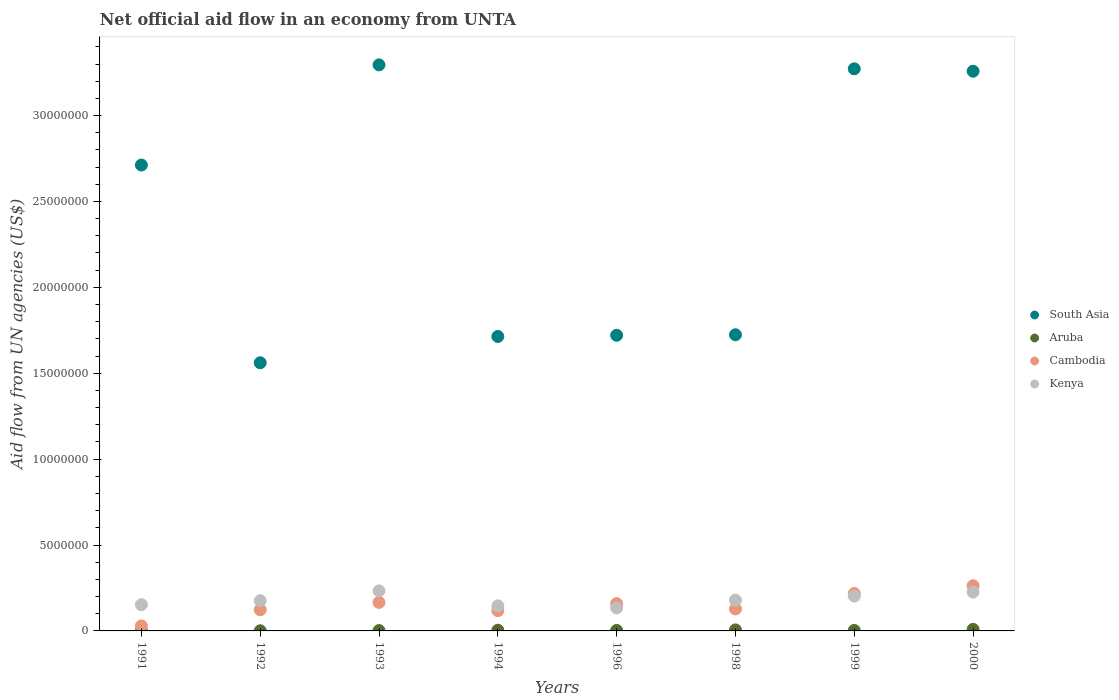What is the net official aid flow in South Asia in 1992?
Provide a succinct answer. 1.56e+07. Across all years, what is the minimum net official aid flow in Aruba?
Make the answer very short. 10000. In which year was the net official aid flow in Kenya maximum?
Make the answer very short. 1993. In which year was the net official aid flow in Cambodia minimum?
Offer a terse response. 1991. What is the total net official aid flow in South Asia in the graph?
Offer a terse response. 1.93e+08. What is the difference between the net official aid flow in Cambodia in 1991 and that in 2000?
Offer a terse response. -2.34e+06. What is the difference between the net official aid flow in Kenya in 1993 and the net official aid flow in Cambodia in 1991?
Keep it short and to the point. 2.04e+06. What is the average net official aid flow in Kenya per year?
Provide a short and direct response. 1.81e+06. In the year 1999, what is the difference between the net official aid flow in Aruba and net official aid flow in South Asia?
Make the answer very short. -3.27e+07. In how many years, is the net official aid flow in Cambodia greater than 25000000 US$?
Give a very brief answer. 0. What is the ratio of the net official aid flow in Cambodia in 1992 to that in 1996?
Ensure brevity in your answer.  0.77. What is the difference between the highest and the second highest net official aid flow in South Asia?
Offer a terse response. 2.30e+05. What is the difference between the highest and the lowest net official aid flow in Kenya?
Your response must be concise. 9.90e+05. Is it the case that in every year, the sum of the net official aid flow in South Asia and net official aid flow in Kenya  is greater than the sum of net official aid flow in Cambodia and net official aid flow in Aruba?
Your response must be concise. No. Is it the case that in every year, the sum of the net official aid flow in Aruba and net official aid flow in South Asia  is greater than the net official aid flow in Kenya?
Offer a terse response. Yes. How many dotlines are there?
Provide a succinct answer. 4. What is the difference between two consecutive major ticks on the Y-axis?
Your answer should be compact. 5.00e+06. Are the values on the major ticks of Y-axis written in scientific E-notation?
Ensure brevity in your answer.  No. Does the graph contain any zero values?
Offer a very short reply. No. Does the graph contain grids?
Provide a succinct answer. No. How are the legend labels stacked?
Your answer should be very brief. Vertical. What is the title of the graph?
Provide a short and direct response. Net official aid flow in an economy from UNTA. Does "Argentina" appear as one of the legend labels in the graph?
Offer a very short reply. No. What is the label or title of the Y-axis?
Your answer should be compact. Aid flow from UN agencies (US$). What is the Aid flow from UN agencies (US$) in South Asia in 1991?
Provide a succinct answer. 2.71e+07. What is the Aid flow from UN agencies (US$) of Cambodia in 1991?
Your answer should be very brief. 2.90e+05. What is the Aid flow from UN agencies (US$) in Kenya in 1991?
Your response must be concise. 1.53e+06. What is the Aid flow from UN agencies (US$) in South Asia in 1992?
Give a very brief answer. 1.56e+07. What is the Aid flow from UN agencies (US$) in Aruba in 1992?
Offer a terse response. 10000. What is the Aid flow from UN agencies (US$) in Cambodia in 1992?
Make the answer very short. 1.23e+06. What is the Aid flow from UN agencies (US$) in Kenya in 1992?
Offer a terse response. 1.76e+06. What is the Aid flow from UN agencies (US$) of South Asia in 1993?
Offer a very short reply. 3.30e+07. What is the Aid flow from UN agencies (US$) of Aruba in 1993?
Your answer should be very brief. 2.00e+04. What is the Aid flow from UN agencies (US$) of Cambodia in 1993?
Provide a succinct answer. 1.66e+06. What is the Aid flow from UN agencies (US$) of Kenya in 1993?
Provide a succinct answer. 2.33e+06. What is the Aid flow from UN agencies (US$) in South Asia in 1994?
Provide a succinct answer. 1.71e+07. What is the Aid flow from UN agencies (US$) in Aruba in 1994?
Ensure brevity in your answer.  4.00e+04. What is the Aid flow from UN agencies (US$) of Cambodia in 1994?
Offer a terse response. 1.18e+06. What is the Aid flow from UN agencies (US$) in Kenya in 1994?
Ensure brevity in your answer.  1.46e+06. What is the Aid flow from UN agencies (US$) in South Asia in 1996?
Your answer should be compact. 1.72e+07. What is the Aid flow from UN agencies (US$) in Aruba in 1996?
Your answer should be very brief. 3.00e+04. What is the Aid flow from UN agencies (US$) of Cambodia in 1996?
Make the answer very short. 1.59e+06. What is the Aid flow from UN agencies (US$) of Kenya in 1996?
Provide a succinct answer. 1.34e+06. What is the Aid flow from UN agencies (US$) of South Asia in 1998?
Provide a short and direct response. 1.72e+07. What is the Aid flow from UN agencies (US$) of Cambodia in 1998?
Ensure brevity in your answer.  1.28e+06. What is the Aid flow from UN agencies (US$) in Kenya in 1998?
Give a very brief answer. 1.79e+06. What is the Aid flow from UN agencies (US$) of South Asia in 1999?
Ensure brevity in your answer.  3.27e+07. What is the Aid flow from UN agencies (US$) in Cambodia in 1999?
Keep it short and to the point. 2.18e+06. What is the Aid flow from UN agencies (US$) of Kenya in 1999?
Keep it short and to the point. 2.03e+06. What is the Aid flow from UN agencies (US$) of South Asia in 2000?
Provide a short and direct response. 3.26e+07. What is the Aid flow from UN agencies (US$) in Aruba in 2000?
Make the answer very short. 9.00e+04. What is the Aid flow from UN agencies (US$) in Cambodia in 2000?
Your answer should be very brief. 2.63e+06. What is the Aid flow from UN agencies (US$) in Kenya in 2000?
Ensure brevity in your answer.  2.26e+06. Across all years, what is the maximum Aid flow from UN agencies (US$) in South Asia?
Give a very brief answer. 3.30e+07. Across all years, what is the maximum Aid flow from UN agencies (US$) in Aruba?
Give a very brief answer. 9.00e+04. Across all years, what is the maximum Aid flow from UN agencies (US$) of Cambodia?
Offer a terse response. 2.63e+06. Across all years, what is the maximum Aid flow from UN agencies (US$) in Kenya?
Provide a short and direct response. 2.33e+06. Across all years, what is the minimum Aid flow from UN agencies (US$) of South Asia?
Give a very brief answer. 1.56e+07. Across all years, what is the minimum Aid flow from UN agencies (US$) in Cambodia?
Offer a terse response. 2.90e+05. Across all years, what is the minimum Aid flow from UN agencies (US$) in Kenya?
Keep it short and to the point. 1.34e+06. What is the total Aid flow from UN agencies (US$) in South Asia in the graph?
Provide a short and direct response. 1.93e+08. What is the total Aid flow from UN agencies (US$) of Cambodia in the graph?
Provide a short and direct response. 1.20e+07. What is the total Aid flow from UN agencies (US$) of Kenya in the graph?
Provide a short and direct response. 1.45e+07. What is the difference between the Aid flow from UN agencies (US$) of South Asia in 1991 and that in 1992?
Keep it short and to the point. 1.15e+07. What is the difference between the Aid flow from UN agencies (US$) in Cambodia in 1991 and that in 1992?
Your answer should be very brief. -9.40e+05. What is the difference between the Aid flow from UN agencies (US$) in South Asia in 1991 and that in 1993?
Offer a very short reply. -5.83e+06. What is the difference between the Aid flow from UN agencies (US$) of Cambodia in 1991 and that in 1993?
Offer a very short reply. -1.37e+06. What is the difference between the Aid flow from UN agencies (US$) of Kenya in 1991 and that in 1993?
Make the answer very short. -8.00e+05. What is the difference between the Aid flow from UN agencies (US$) in South Asia in 1991 and that in 1994?
Your response must be concise. 9.98e+06. What is the difference between the Aid flow from UN agencies (US$) in Aruba in 1991 and that in 1994?
Give a very brief answer. -3.00e+04. What is the difference between the Aid flow from UN agencies (US$) of Cambodia in 1991 and that in 1994?
Keep it short and to the point. -8.90e+05. What is the difference between the Aid flow from UN agencies (US$) in South Asia in 1991 and that in 1996?
Give a very brief answer. 9.91e+06. What is the difference between the Aid flow from UN agencies (US$) of Cambodia in 1991 and that in 1996?
Your answer should be compact. -1.30e+06. What is the difference between the Aid flow from UN agencies (US$) of South Asia in 1991 and that in 1998?
Provide a short and direct response. 9.88e+06. What is the difference between the Aid flow from UN agencies (US$) in Cambodia in 1991 and that in 1998?
Your response must be concise. -9.90e+05. What is the difference between the Aid flow from UN agencies (US$) in South Asia in 1991 and that in 1999?
Offer a terse response. -5.60e+06. What is the difference between the Aid flow from UN agencies (US$) of Aruba in 1991 and that in 1999?
Your answer should be very brief. -2.00e+04. What is the difference between the Aid flow from UN agencies (US$) in Cambodia in 1991 and that in 1999?
Ensure brevity in your answer.  -1.89e+06. What is the difference between the Aid flow from UN agencies (US$) in Kenya in 1991 and that in 1999?
Offer a terse response. -5.00e+05. What is the difference between the Aid flow from UN agencies (US$) of South Asia in 1991 and that in 2000?
Ensure brevity in your answer.  -5.46e+06. What is the difference between the Aid flow from UN agencies (US$) of Cambodia in 1991 and that in 2000?
Your answer should be very brief. -2.34e+06. What is the difference between the Aid flow from UN agencies (US$) in Kenya in 1991 and that in 2000?
Make the answer very short. -7.30e+05. What is the difference between the Aid flow from UN agencies (US$) of South Asia in 1992 and that in 1993?
Keep it short and to the point. -1.73e+07. What is the difference between the Aid flow from UN agencies (US$) of Aruba in 1992 and that in 1993?
Ensure brevity in your answer.  -10000. What is the difference between the Aid flow from UN agencies (US$) of Cambodia in 1992 and that in 1993?
Make the answer very short. -4.30e+05. What is the difference between the Aid flow from UN agencies (US$) in Kenya in 1992 and that in 1993?
Give a very brief answer. -5.70e+05. What is the difference between the Aid flow from UN agencies (US$) of South Asia in 1992 and that in 1994?
Ensure brevity in your answer.  -1.53e+06. What is the difference between the Aid flow from UN agencies (US$) of Aruba in 1992 and that in 1994?
Ensure brevity in your answer.  -3.00e+04. What is the difference between the Aid flow from UN agencies (US$) of Cambodia in 1992 and that in 1994?
Provide a short and direct response. 5.00e+04. What is the difference between the Aid flow from UN agencies (US$) in South Asia in 1992 and that in 1996?
Your response must be concise. -1.60e+06. What is the difference between the Aid flow from UN agencies (US$) in Aruba in 1992 and that in 1996?
Keep it short and to the point. -2.00e+04. What is the difference between the Aid flow from UN agencies (US$) in Cambodia in 1992 and that in 1996?
Give a very brief answer. -3.60e+05. What is the difference between the Aid flow from UN agencies (US$) of South Asia in 1992 and that in 1998?
Provide a short and direct response. -1.63e+06. What is the difference between the Aid flow from UN agencies (US$) in Aruba in 1992 and that in 1998?
Provide a succinct answer. -5.00e+04. What is the difference between the Aid flow from UN agencies (US$) of South Asia in 1992 and that in 1999?
Keep it short and to the point. -1.71e+07. What is the difference between the Aid flow from UN agencies (US$) of Aruba in 1992 and that in 1999?
Ensure brevity in your answer.  -2.00e+04. What is the difference between the Aid flow from UN agencies (US$) in Cambodia in 1992 and that in 1999?
Offer a very short reply. -9.50e+05. What is the difference between the Aid flow from UN agencies (US$) in Kenya in 1992 and that in 1999?
Provide a succinct answer. -2.70e+05. What is the difference between the Aid flow from UN agencies (US$) of South Asia in 1992 and that in 2000?
Your response must be concise. -1.70e+07. What is the difference between the Aid flow from UN agencies (US$) in Aruba in 1992 and that in 2000?
Your answer should be very brief. -8.00e+04. What is the difference between the Aid flow from UN agencies (US$) in Cambodia in 1992 and that in 2000?
Give a very brief answer. -1.40e+06. What is the difference between the Aid flow from UN agencies (US$) in Kenya in 1992 and that in 2000?
Offer a very short reply. -5.00e+05. What is the difference between the Aid flow from UN agencies (US$) of South Asia in 1993 and that in 1994?
Make the answer very short. 1.58e+07. What is the difference between the Aid flow from UN agencies (US$) in Aruba in 1993 and that in 1994?
Offer a terse response. -2.00e+04. What is the difference between the Aid flow from UN agencies (US$) in Kenya in 1993 and that in 1994?
Offer a very short reply. 8.70e+05. What is the difference between the Aid flow from UN agencies (US$) in South Asia in 1993 and that in 1996?
Keep it short and to the point. 1.57e+07. What is the difference between the Aid flow from UN agencies (US$) in Aruba in 1993 and that in 1996?
Your answer should be compact. -10000. What is the difference between the Aid flow from UN agencies (US$) in Kenya in 1993 and that in 1996?
Make the answer very short. 9.90e+05. What is the difference between the Aid flow from UN agencies (US$) of South Asia in 1993 and that in 1998?
Offer a very short reply. 1.57e+07. What is the difference between the Aid flow from UN agencies (US$) of Kenya in 1993 and that in 1998?
Keep it short and to the point. 5.40e+05. What is the difference between the Aid flow from UN agencies (US$) in Cambodia in 1993 and that in 1999?
Make the answer very short. -5.20e+05. What is the difference between the Aid flow from UN agencies (US$) of Cambodia in 1993 and that in 2000?
Provide a short and direct response. -9.70e+05. What is the difference between the Aid flow from UN agencies (US$) of Kenya in 1993 and that in 2000?
Make the answer very short. 7.00e+04. What is the difference between the Aid flow from UN agencies (US$) of South Asia in 1994 and that in 1996?
Keep it short and to the point. -7.00e+04. What is the difference between the Aid flow from UN agencies (US$) in Aruba in 1994 and that in 1996?
Offer a very short reply. 10000. What is the difference between the Aid flow from UN agencies (US$) in Cambodia in 1994 and that in 1996?
Your response must be concise. -4.10e+05. What is the difference between the Aid flow from UN agencies (US$) in South Asia in 1994 and that in 1998?
Ensure brevity in your answer.  -1.00e+05. What is the difference between the Aid flow from UN agencies (US$) of Aruba in 1994 and that in 1998?
Your response must be concise. -2.00e+04. What is the difference between the Aid flow from UN agencies (US$) of Kenya in 1994 and that in 1998?
Offer a terse response. -3.30e+05. What is the difference between the Aid flow from UN agencies (US$) in South Asia in 1994 and that in 1999?
Offer a terse response. -1.56e+07. What is the difference between the Aid flow from UN agencies (US$) in Kenya in 1994 and that in 1999?
Keep it short and to the point. -5.70e+05. What is the difference between the Aid flow from UN agencies (US$) in South Asia in 1994 and that in 2000?
Give a very brief answer. -1.54e+07. What is the difference between the Aid flow from UN agencies (US$) of Cambodia in 1994 and that in 2000?
Keep it short and to the point. -1.45e+06. What is the difference between the Aid flow from UN agencies (US$) of Kenya in 1994 and that in 2000?
Provide a succinct answer. -8.00e+05. What is the difference between the Aid flow from UN agencies (US$) in South Asia in 1996 and that in 1998?
Provide a short and direct response. -3.00e+04. What is the difference between the Aid flow from UN agencies (US$) in Aruba in 1996 and that in 1998?
Provide a succinct answer. -3.00e+04. What is the difference between the Aid flow from UN agencies (US$) in Cambodia in 1996 and that in 1998?
Offer a terse response. 3.10e+05. What is the difference between the Aid flow from UN agencies (US$) of Kenya in 1996 and that in 1998?
Give a very brief answer. -4.50e+05. What is the difference between the Aid flow from UN agencies (US$) in South Asia in 1996 and that in 1999?
Offer a terse response. -1.55e+07. What is the difference between the Aid flow from UN agencies (US$) of Cambodia in 1996 and that in 1999?
Your response must be concise. -5.90e+05. What is the difference between the Aid flow from UN agencies (US$) in Kenya in 1996 and that in 1999?
Provide a short and direct response. -6.90e+05. What is the difference between the Aid flow from UN agencies (US$) of South Asia in 1996 and that in 2000?
Keep it short and to the point. -1.54e+07. What is the difference between the Aid flow from UN agencies (US$) of Cambodia in 1996 and that in 2000?
Your answer should be compact. -1.04e+06. What is the difference between the Aid flow from UN agencies (US$) in Kenya in 1996 and that in 2000?
Give a very brief answer. -9.20e+05. What is the difference between the Aid flow from UN agencies (US$) in South Asia in 1998 and that in 1999?
Make the answer very short. -1.55e+07. What is the difference between the Aid flow from UN agencies (US$) in Aruba in 1998 and that in 1999?
Your answer should be very brief. 3.00e+04. What is the difference between the Aid flow from UN agencies (US$) of Cambodia in 1998 and that in 1999?
Make the answer very short. -9.00e+05. What is the difference between the Aid flow from UN agencies (US$) of Kenya in 1998 and that in 1999?
Give a very brief answer. -2.40e+05. What is the difference between the Aid flow from UN agencies (US$) in South Asia in 1998 and that in 2000?
Offer a terse response. -1.53e+07. What is the difference between the Aid flow from UN agencies (US$) of Aruba in 1998 and that in 2000?
Provide a short and direct response. -3.00e+04. What is the difference between the Aid flow from UN agencies (US$) of Cambodia in 1998 and that in 2000?
Your answer should be very brief. -1.35e+06. What is the difference between the Aid flow from UN agencies (US$) in Kenya in 1998 and that in 2000?
Your answer should be compact. -4.70e+05. What is the difference between the Aid flow from UN agencies (US$) in Aruba in 1999 and that in 2000?
Your response must be concise. -6.00e+04. What is the difference between the Aid flow from UN agencies (US$) in Cambodia in 1999 and that in 2000?
Make the answer very short. -4.50e+05. What is the difference between the Aid flow from UN agencies (US$) in Kenya in 1999 and that in 2000?
Your answer should be very brief. -2.30e+05. What is the difference between the Aid flow from UN agencies (US$) in South Asia in 1991 and the Aid flow from UN agencies (US$) in Aruba in 1992?
Provide a short and direct response. 2.71e+07. What is the difference between the Aid flow from UN agencies (US$) of South Asia in 1991 and the Aid flow from UN agencies (US$) of Cambodia in 1992?
Make the answer very short. 2.59e+07. What is the difference between the Aid flow from UN agencies (US$) of South Asia in 1991 and the Aid flow from UN agencies (US$) of Kenya in 1992?
Make the answer very short. 2.54e+07. What is the difference between the Aid flow from UN agencies (US$) of Aruba in 1991 and the Aid flow from UN agencies (US$) of Cambodia in 1992?
Your answer should be compact. -1.22e+06. What is the difference between the Aid flow from UN agencies (US$) in Aruba in 1991 and the Aid flow from UN agencies (US$) in Kenya in 1992?
Your response must be concise. -1.75e+06. What is the difference between the Aid flow from UN agencies (US$) of Cambodia in 1991 and the Aid flow from UN agencies (US$) of Kenya in 1992?
Ensure brevity in your answer.  -1.47e+06. What is the difference between the Aid flow from UN agencies (US$) of South Asia in 1991 and the Aid flow from UN agencies (US$) of Aruba in 1993?
Make the answer very short. 2.71e+07. What is the difference between the Aid flow from UN agencies (US$) in South Asia in 1991 and the Aid flow from UN agencies (US$) in Cambodia in 1993?
Keep it short and to the point. 2.55e+07. What is the difference between the Aid flow from UN agencies (US$) in South Asia in 1991 and the Aid flow from UN agencies (US$) in Kenya in 1993?
Offer a very short reply. 2.48e+07. What is the difference between the Aid flow from UN agencies (US$) in Aruba in 1991 and the Aid flow from UN agencies (US$) in Cambodia in 1993?
Make the answer very short. -1.65e+06. What is the difference between the Aid flow from UN agencies (US$) of Aruba in 1991 and the Aid flow from UN agencies (US$) of Kenya in 1993?
Give a very brief answer. -2.32e+06. What is the difference between the Aid flow from UN agencies (US$) of Cambodia in 1991 and the Aid flow from UN agencies (US$) of Kenya in 1993?
Ensure brevity in your answer.  -2.04e+06. What is the difference between the Aid flow from UN agencies (US$) in South Asia in 1991 and the Aid flow from UN agencies (US$) in Aruba in 1994?
Provide a succinct answer. 2.71e+07. What is the difference between the Aid flow from UN agencies (US$) of South Asia in 1991 and the Aid flow from UN agencies (US$) of Cambodia in 1994?
Offer a terse response. 2.59e+07. What is the difference between the Aid flow from UN agencies (US$) in South Asia in 1991 and the Aid flow from UN agencies (US$) in Kenya in 1994?
Your answer should be compact. 2.57e+07. What is the difference between the Aid flow from UN agencies (US$) of Aruba in 1991 and the Aid flow from UN agencies (US$) of Cambodia in 1994?
Provide a succinct answer. -1.17e+06. What is the difference between the Aid flow from UN agencies (US$) in Aruba in 1991 and the Aid flow from UN agencies (US$) in Kenya in 1994?
Your answer should be very brief. -1.45e+06. What is the difference between the Aid flow from UN agencies (US$) of Cambodia in 1991 and the Aid flow from UN agencies (US$) of Kenya in 1994?
Your answer should be very brief. -1.17e+06. What is the difference between the Aid flow from UN agencies (US$) of South Asia in 1991 and the Aid flow from UN agencies (US$) of Aruba in 1996?
Ensure brevity in your answer.  2.71e+07. What is the difference between the Aid flow from UN agencies (US$) of South Asia in 1991 and the Aid flow from UN agencies (US$) of Cambodia in 1996?
Keep it short and to the point. 2.55e+07. What is the difference between the Aid flow from UN agencies (US$) in South Asia in 1991 and the Aid flow from UN agencies (US$) in Kenya in 1996?
Ensure brevity in your answer.  2.58e+07. What is the difference between the Aid flow from UN agencies (US$) of Aruba in 1991 and the Aid flow from UN agencies (US$) of Cambodia in 1996?
Provide a short and direct response. -1.58e+06. What is the difference between the Aid flow from UN agencies (US$) of Aruba in 1991 and the Aid flow from UN agencies (US$) of Kenya in 1996?
Provide a succinct answer. -1.33e+06. What is the difference between the Aid flow from UN agencies (US$) of Cambodia in 1991 and the Aid flow from UN agencies (US$) of Kenya in 1996?
Make the answer very short. -1.05e+06. What is the difference between the Aid flow from UN agencies (US$) of South Asia in 1991 and the Aid flow from UN agencies (US$) of Aruba in 1998?
Ensure brevity in your answer.  2.71e+07. What is the difference between the Aid flow from UN agencies (US$) of South Asia in 1991 and the Aid flow from UN agencies (US$) of Cambodia in 1998?
Your answer should be very brief. 2.58e+07. What is the difference between the Aid flow from UN agencies (US$) of South Asia in 1991 and the Aid flow from UN agencies (US$) of Kenya in 1998?
Your answer should be compact. 2.53e+07. What is the difference between the Aid flow from UN agencies (US$) in Aruba in 1991 and the Aid flow from UN agencies (US$) in Cambodia in 1998?
Make the answer very short. -1.27e+06. What is the difference between the Aid flow from UN agencies (US$) in Aruba in 1991 and the Aid flow from UN agencies (US$) in Kenya in 1998?
Your response must be concise. -1.78e+06. What is the difference between the Aid flow from UN agencies (US$) in Cambodia in 1991 and the Aid flow from UN agencies (US$) in Kenya in 1998?
Give a very brief answer. -1.50e+06. What is the difference between the Aid flow from UN agencies (US$) in South Asia in 1991 and the Aid flow from UN agencies (US$) in Aruba in 1999?
Your response must be concise. 2.71e+07. What is the difference between the Aid flow from UN agencies (US$) of South Asia in 1991 and the Aid flow from UN agencies (US$) of Cambodia in 1999?
Offer a very short reply. 2.49e+07. What is the difference between the Aid flow from UN agencies (US$) of South Asia in 1991 and the Aid flow from UN agencies (US$) of Kenya in 1999?
Make the answer very short. 2.51e+07. What is the difference between the Aid flow from UN agencies (US$) of Aruba in 1991 and the Aid flow from UN agencies (US$) of Cambodia in 1999?
Your response must be concise. -2.17e+06. What is the difference between the Aid flow from UN agencies (US$) of Aruba in 1991 and the Aid flow from UN agencies (US$) of Kenya in 1999?
Your response must be concise. -2.02e+06. What is the difference between the Aid flow from UN agencies (US$) of Cambodia in 1991 and the Aid flow from UN agencies (US$) of Kenya in 1999?
Your answer should be very brief. -1.74e+06. What is the difference between the Aid flow from UN agencies (US$) in South Asia in 1991 and the Aid flow from UN agencies (US$) in Aruba in 2000?
Your response must be concise. 2.70e+07. What is the difference between the Aid flow from UN agencies (US$) in South Asia in 1991 and the Aid flow from UN agencies (US$) in Cambodia in 2000?
Provide a succinct answer. 2.45e+07. What is the difference between the Aid flow from UN agencies (US$) of South Asia in 1991 and the Aid flow from UN agencies (US$) of Kenya in 2000?
Offer a very short reply. 2.49e+07. What is the difference between the Aid flow from UN agencies (US$) in Aruba in 1991 and the Aid flow from UN agencies (US$) in Cambodia in 2000?
Your response must be concise. -2.62e+06. What is the difference between the Aid flow from UN agencies (US$) in Aruba in 1991 and the Aid flow from UN agencies (US$) in Kenya in 2000?
Give a very brief answer. -2.25e+06. What is the difference between the Aid flow from UN agencies (US$) in Cambodia in 1991 and the Aid flow from UN agencies (US$) in Kenya in 2000?
Provide a short and direct response. -1.97e+06. What is the difference between the Aid flow from UN agencies (US$) in South Asia in 1992 and the Aid flow from UN agencies (US$) in Aruba in 1993?
Your response must be concise. 1.56e+07. What is the difference between the Aid flow from UN agencies (US$) in South Asia in 1992 and the Aid flow from UN agencies (US$) in Cambodia in 1993?
Provide a short and direct response. 1.40e+07. What is the difference between the Aid flow from UN agencies (US$) of South Asia in 1992 and the Aid flow from UN agencies (US$) of Kenya in 1993?
Ensure brevity in your answer.  1.33e+07. What is the difference between the Aid flow from UN agencies (US$) of Aruba in 1992 and the Aid flow from UN agencies (US$) of Cambodia in 1993?
Your answer should be compact. -1.65e+06. What is the difference between the Aid flow from UN agencies (US$) in Aruba in 1992 and the Aid flow from UN agencies (US$) in Kenya in 1993?
Your response must be concise. -2.32e+06. What is the difference between the Aid flow from UN agencies (US$) in Cambodia in 1992 and the Aid flow from UN agencies (US$) in Kenya in 1993?
Provide a succinct answer. -1.10e+06. What is the difference between the Aid flow from UN agencies (US$) of South Asia in 1992 and the Aid flow from UN agencies (US$) of Aruba in 1994?
Give a very brief answer. 1.56e+07. What is the difference between the Aid flow from UN agencies (US$) in South Asia in 1992 and the Aid flow from UN agencies (US$) in Cambodia in 1994?
Offer a terse response. 1.44e+07. What is the difference between the Aid flow from UN agencies (US$) in South Asia in 1992 and the Aid flow from UN agencies (US$) in Kenya in 1994?
Give a very brief answer. 1.42e+07. What is the difference between the Aid flow from UN agencies (US$) in Aruba in 1992 and the Aid flow from UN agencies (US$) in Cambodia in 1994?
Provide a short and direct response. -1.17e+06. What is the difference between the Aid flow from UN agencies (US$) in Aruba in 1992 and the Aid flow from UN agencies (US$) in Kenya in 1994?
Your answer should be compact. -1.45e+06. What is the difference between the Aid flow from UN agencies (US$) in South Asia in 1992 and the Aid flow from UN agencies (US$) in Aruba in 1996?
Ensure brevity in your answer.  1.56e+07. What is the difference between the Aid flow from UN agencies (US$) of South Asia in 1992 and the Aid flow from UN agencies (US$) of Cambodia in 1996?
Ensure brevity in your answer.  1.40e+07. What is the difference between the Aid flow from UN agencies (US$) in South Asia in 1992 and the Aid flow from UN agencies (US$) in Kenya in 1996?
Provide a short and direct response. 1.43e+07. What is the difference between the Aid flow from UN agencies (US$) in Aruba in 1992 and the Aid flow from UN agencies (US$) in Cambodia in 1996?
Offer a very short reply. -1.58e+06. What is the difference between the Aid flow from UN agencies (US$) of Aruba in 1992 and the Aid flow from UN agencies (US$) of Kenya in 1996?
Your response must be concise. -1.33e+06. What is the difference between the Aid flow from UN agencies (US$) in Cambodia in 1992 and the Aid flow from UN agencies (US$) in Kenya in 1996?
Keep it short and to the point. -1.10e+05. What is the difference between the Aid flow from UN agencies (US$) in South Asia in 1992 and the Aid flow from UN agencies (US$) in Aruba in 1998?
Provide a succinct answer. 1.56e+07. What is the difference between the Aid flow from UN agencies (US$) of South Asia in 1992 and the Aid flow from UN agencies (US$) of Cambodia in 1998?
Provide a short and direct response. 1.43e+07. What is the difference between the Aid flow from UN agencies (US$) of South Asia in 1992 and the Aid flow from UN agencies (US$) of Kenya in 1998?
Give a very brief answer. 1.38e+07. What is the difference between the Aid flow from UN agencies (US$) in Aruba in 1992 and the Aid flow from UN agencies (US$) in Cambodia in 1998?
Provide a succinct answer. -1.27e+06. What is the difference between the Aid flow from UN agencies (US$) in Aruba in 1992 and the Aid flow from UN agencies (US$) in Kenya in 1998?
Make the answer very short. -1.78e+06. What is the difference between the Aid flow from UN agencies (US$) of Cambodia in 1992 and the Aid flow from UN agencies (US$) of Kenya in 1998?
Your answer should be very brief. -5.60e+05. What is the difference between the Aid flow from UN agencies (US$) of South Asia in 1992 and the Aid flow from UN agencies (US$) of Aruba in 1999?
Make the answer very short. 1.56e+07. What is the difference between the Aid flow from UN agencies (US$) in South Asia in 1992 and the Aid flow from UN agencies (US$) in Cambodia in 1999?
Offer a very short reply. 1.34e+07. What is the difference between the Aid flow from UN agencies (US$) of South Asia in 1992 and the Aid flow from UN agencies (US$) of Kenya in 1999?
Ensure brevity in your answer.  1.36e+07. What is the difference between the Aid flow from UN agencies (US$) of Aruba in 1992 and the Aid flow from UN agencies (US$) of Cambodia in 1999?
Give a very brief answer. -2.17e+06. What is the difference between the Aid flow from UN agencies (US$) of Aruba in 1992 and the Aid flow from UN agencies (US$) of Kenya in 1999?
Your response must be concise. -2.02e+06. What is the difference between the Aid flow from UN agencies (US$) of Cambodia in 1992 and the Aid flow from UN agencies (US$) of Kenya in 1999?
Make the answer very short. -8.00e+05. What is the difference between the Aid flow from UN agencies (US$) of South Asia in 1992 and the Aid flow from UN agencies (US$) of Aruba in 2000?
Your answer should be compact. 1.55e+07. What is the difference between the Aid flow from UN agencies (US$) of South Asia in 1992 and the Aid flow from UN agencies (US$) of Cambodia in 2000?
Offer a very short reply. 1.30e+07. What is the difference between the Aid flow from UN agencies (US$) in South Asia in 1992 and the Aid flow from UN agencies (US$) in Kenya in 2000?
Offer a terse response. 1.34e+07. What is the difference between the Aid flow from UN agencies (US$) in Aruba in 1992 and the Aid flow from UN agencies (US$) in Cambodia in 2000?
Provide a short and direct response. -2.62e+06. What is the difference between the Aid flow from UN agencies (US$) of Aruba in 1992 and the Aid flow from UN agencies (US$) of Kenya in 2000?
Keep it short and to the point. -2.25e+06. What is the difference between the Aid flow from UN agencies (US$) in Cambodia in 1992 and the Aid flow from UN agencies (US$) in Kenya in 2000?
Make the answer very short. -1.03e+06. What is the difference between the Aid flow from UN agencies (US$) in South Asia in 1993 and the Aid flow from UN agencies (US$) in Aruba in 1994?
Offer a terse response. 3.29e+07. What is the difference between the Aid flow from UN agencies (US$) of South Asia in 1993 and the Aid flow from UN agencies (US$) of Cambodia in 1994?
Give a very brief answer. 3.18e+07. What is the difference between the Aid flow from UN agencies (US$) of South Asia in 1993 and the Aid flow from UN agencies (US$) of Kenya in 1994?
Make the answer very short. 3.15e+07. What is the difference between the Aid flow from UN agencies (US$) of Aruba in 1993 and the Aid flow from UN agencies (US$) of Cambodia in 1994?
Your response must be concise. -1.16e+06. What is the difference between the Aid flow from UN agencies (US$) in Aruba in 1993 and the Aid flow from UN agencies (US$) in Kenya in 1994?
Ensure brevity in your answer.  -1.44e+06. What is the difference between the Aid flow from UN agencies (US$) in South Asia in 1993 and the Aid flow from UN agencies (US$) in Aruba in 1996?
Provide a short and direct response. 3.29e+07. What is the difference between the Aid flow from UN agencies (US$) in South Asia in 1993 and the Aid flow from UN agencies (US$) in Cambodia in 1996?
Offer a terse response. 3.14e+07. What is the difference between the Aid flow from UN agencies (US$) of South Asia in 1993 and the Aid flow from UN agencies (US$) of Kenya in 1996?
Your response must be concise. 3.16e+07. What is the difference between the Aid flow from UN agencies (US$) of Aruba in 1993 and the Aid flow from UN agencies (US$) of Cambodia in 1996?
Ensure brevity in your answer.  -1.57e+06. What is the difference between the Aid flow from UN agencies (US$) in Aruba in 1993 and the Aid flow from UN agencies (US$) in Kenya in 1996?
Your answer should be compact. -1.32e+06. What is the difference between the Aid flow from UN agencies (US$) of Cambodia in 1993 and the Aid flow from UN agencies (US$) of Kenya in 1996?
Ensure brevity in your answer.  3.20e+05. What is the difference between the Aid flow from UN agencies (US$) of South Asia in 1993 and the Aid flow from UN agencies (US$) of Aruba in 1998?
Give a very brief answer. 3.29e+07. What is the difference between the Aid flow from UN agencies (US$) of South Asia in 1993 and the Aid flow from UN agencies (US$) of Cambodia in 1998?
Keep it short and to the point. 3.17e+07. What is the difference between the Aid flow from UN agencies (US$) of South Asia in 1993 and the Aid flow from UN agencies (US$) of Kenya in 1998?
Your response must be concise. 3.12e+07. What is the difference between the Aid flow from UN agencies (US$) in Aruba in 1993 and the Aid flow from UN agencies (US$) in Cambodia in 1998?
Offer a very short reply. -1.26e+06. What is the difference between the Aid flow from UN agencies (US$) in Aruba in 1993 and the Aid flow from UN agencies (US$) in Kenya in 1998?
Keep it short and to the point. -1.77e+06. What is the difference between the Aid flow from UN agencies (US$) of Cambodia in 1993 and the Aid flow from UN agencies (US$) of Kenya in 1998?
Make the answer very short. -1.30e+05. What is the difference between the Aid flow from UN agencies (US$) in South Asia in 1993 and the Aid flow from UN agencies (US$) in Aruba in 1999?
Offer a very short reply. 3.29e+07. What is the difference between the Aid flow from UN agencies (US$) in South Asia in 1993 and the Aid flow from UN agencies (US$) in Cambodia in 1999?
Keep it short and to the point. 3.08e+07. What is the difference between the Aid flow from UN agencies (US$) of South Asia in 1993 and the Aid flow from UN agencies (US$) of Kenya in 1999?
Your response must be concise. 3.09e+07. What is the difference between the Aid flow from UN agencies (US$) of Aruba in 1993 and the Aid flow from UN agencies (US$) of Cambodia in 1999?
Ensure brevity in your answer.  -2.16e+06. What is the difference between the Aid flow from UN agencies (US$) in Aruba in 1993 and the Aid flow from UN agencies (US$) in Kenya in 1999?
Provide a short and direct response. -2.01e+06. What is the difference between the Aid flow from UN agencies (US$) in Cambodia in 1993 and the Aid flow from UN agencies (US$) in Kenya in 1999?
Your answer should be very brief. -3.70e+05. What is the difference between the Aid flow from UN agencies (US$) in South Asia in 1993 and the Aid flow from UN agencies (US$) in Aruba in 2000?
Offer a very short reply. 3.29e+07. What is the difference between the Aid flow from UN agencies (US$) in South Asia in 1993 and the Aid flow from UN agencies (US$) in Cambodia in 2000?
Provide a short and direct response. 3.03e+07. What is the difference between the Aid flow from UN agencies (US$) in South Asia in 1993 and the Aid flow from UN agencies (US$) in Kenya in 2000?
Make the answer very short. 3.07e+07. What is the difference between the Aid flow from UN agencies (US$) of Aruba in 1993 and the Aid flow from UN agencies (US$) of Cambodia in 2000?
Your response must be concise. -2.61e+06. What is the difference between the Aid flow from UN agencies (US$) in Aruba in 1993 and the Aid flow from UN agencies (US$) in Kenya in 2000?
Your answer should be very brief. -2.24e+06. What is the difference between the Aid flow from UN agencies (US$) in Cambodia in 1993 and the Aid flow from UN agencies (US$) in Kenya in 2000?
Make the answer very short. -6.00e+05. What is the difference between the Aid flow from UN agencies (US$) in South Asia in 1994 and the Aid flow from UN agencies (US$) in Aruba in 1996?
Provide a short and direct response. 1.71e+07. What is the difference between the Aid flow from UN agencies (US$) of South Asia in 1994 and the Aid flow from UN agencies (US$) of Cambodia in 1996?
Your answer should be very brief. 1.56e+07. What is the difference between the Aid flow from UN agencies (US$) in South Asia in 1994 and the Aid flow from UN agencies (US$) in Kenya in 1996?
Provide a succinct answer. 1.58e+07. What is the difference between the Aid flow from UN agencies (US$) of Aruba in 1994 and the Aid flow from UN agencies (US$) of Cambodia in 1996?
Ensure brevity in your answer.  -1.55e+06. What is the difference between the Aid flow from UN agencies (US$) of Aruba in 1994 and the Aid flow from UN agencies (US$) of Kenya in 1996?
Provide a short and direct response. -1.30e+06. What is the difference between the Aid flow from UN agencies (US$) of Cambodia in 1994 and the Aid flow from UN agencies (US$) of Kenya in 1996?
Offer a very short reply. -1.60e+05. What is the difference between the Aid flow from UN agencies (US$) in South Asia in 1994 and the Aid flow from UN agencies (US$) in Aruba in 1998?
Provide a succinct answer. 1.71e+07. What is the difference between the Aid flow from UN agencies (US$) in South Asia in 1994 and the Aid flow from UN agencies (US$) in Cambodia in 1998?
Your answer should be compact. 1.59e+07. What is the difference between the Aid flow from UN agencies (US$) of South Asia in 1994 and the Aid flow from UN agencies (US$) of Kenya in 1998?
Provide a short and direct response. 1.54e+07. What is the difference between the Aid flow from UN agencies (US$) of Aruba in 1994 and the Aid flow from UN agencies (US$) of Cambodia in 1998?
Give a very brief answer. -1.24e+06. What is the difference between the Aid flow from UN agencies (US$) of Aruba in 1994 and the Aid flow from UN agencies (US$) of Kenya in 1998?
Provide a succinct answer. -1.75e+06. What is the difference between the Aid flow from UN agencies (US$) of Cambodia in 1994 and the Aid flow from UN agencies (US$) of Kenya in 1998?
Provide a succinct answer. -6.10e+05. What is the difference between the Aid flow from UN agencies (US$) in South Asia in 1994 and the Aid flow from UN agencies (US$) in Aruba in 1999?
Make the answer very short. 1.71e+07. What is the difference between the Aid flow from UN agencies (US$) of South Asia in 1994 and the Aid flow from UN agencies (US$) of Cambodia in 1999?
Offer a terse response. 1.50e+07. What is the difference between the Aid flow from UN agencies (US$) in South Asia in 1994 and the Aid flow from UN agencies (US$) in Kenya in 1999?
Make the answer very short. 1.51e+07. What is the difference between the Aid flow from UN agencies (US$) of Aruba in 1994 and the Aid flow from UN agencies (US$) of Cambodia in 1999?
Offer a terse response. -2.14e+06. What is the difference between the Aid flow from UN agencies (US$) of Aruba in 1994 and the Aid flow from UN agencies (US$) of Kenya in 1999?
Make the answer very short. -1.99e+06. What is the difference between the Aid flow from UN agencies (US$) in Cambodia in 1994 and the Aid flow from UN agencies (US$) in Kenya in 1999?
Your answer should be very brief. -8.50e+05. What is the difference between the Aid flow from UN agencies (US$) in South Asia in 1994 and the Aid flow from UN agencies (US$) in Aruba in 2000?
Your answer should be very brief. 1.70e+07. What is the difference between the Aid flow from UN agencies (US$) of South Asia in 1994 and the Aid flow from UN agencies (US$) of Cambodia in 2000?
Offer a terse response. 1.45e+07. What is the difference between the Aid flow from UN agencies (US$) of South Asia in 1994 and the Aid flow from UN agencies (US$) of Kenya in 2000?
Ensure brevity in your answer.  1.49e+07. What is the difference between the Aid flow from UN agencies (US$) of Aruba in 1994 and the Aid flow from UN agencies (US$) of Cambodia in 2000?
Provide a short and direct response. -2.59e+06. What is the difference between the Aid flow from UN agencies (US$) in Aruba in 1994 and the Aid flow from UN agencies (US$) in Kenya in 2000?
Ensure brevity in your answer.  -2.22e+06. What is the difference between the Aid flow from UN agencies (US$) of Cambodia in 1994 and the Aid flow from UN agencies (US$) of Kenya in 2000?
Offer a very short reply. -1.08e+06. What is the difference between the Aid flow from UN agencies (US$) in South Asia in 1996 and the Aid flow from UN agencies (US$) in Aruba in 1998?
Keep it short and to the point. 1.72e+07. What is the difference between the Aid flow from UN agencies (US$) in South Asia in 1996 and the Aid flow from UN agencies (US$) in Cambodia in 1998?
Provide a short and direct response. 1.59e+07. What is the difference between the Aid flow from UN agencies (US$) in South Asia in 1996 and the Aid flow from UN agencies (US$) in Kenya in 1998?
Keep it short and to the point. 1.54e+07. What is the difference between the Aid flow from UN agencies (US$) of Aruba in 1996 and the Aid flow from UN agencies (US$) of Cambodia in 1998?
Keep it short and to the point. -1.25e+06. What is the difference between the Aid flow from UN agencies (US$) of Aruba in 1996 and the Aid flow from UN agencies (US$) of Kenya in 1998?
Provide a succinct answer. -1.76e+06. What is the difference between the Aid flow from UN agencies (US$) of Cambodia in 1996 and the Aid flow from UN agencies (US$) of Kenya in 1998?
Provide a short and direct response. -2.00e+05. What is the difference between the Aid flow from UN agencies (US$) in South Asia in 1996 and the Aid flow from UN agencies (US$) in Aruba in 1999?
Provide a short and direct response. 1.72e+07. What is the difference between the Aid flow from UN agencies (US$) of South Asia in 1996 and the Aid flow from UN agencies (US$) of Cambodia in 1999?
Make the answer very short. 1.50e+07. What is the difference between the Aid flow from UN agencies (US$) of South Asia in 1996 and the Aid flow from UN agencies (US$) of Kenya in 1999?
Offer a very short reply. 1.52e+07. What is the difference between the Aid flow from UN agencies (US$) of Aruba in 1996 and the Aid flow from UN agencies (US$) of Cambodia in 1999?
Make the answer very short. -2.15e+06. What is the difference between the Aid flow from UN agencies (US$) in Cambodia in 1996 and the Aid flow from UN agencies (US$) in Kenya in 1999?
Your answer should be very brief. -4.40e+05. What is the difference between the Aid flow from UN agencies (US$) in South Asia in 1996 and the Aid flow from UN agencies (US$) in Aruba in 2000?
Your answer should be compact. 1.71e+07. What is the difference between the Aid flow from UN agencies (US$) of South Asia in 1996 and the Aid flow from UN agencies (US$) of Cambodia in 2000?
Provide a succinct answer. 1.46e+07. What is the difference between the Aid flow from UN agencies (US$) of South Asia in 1996 and the Aid flow from UN agencies (US$) of Kenya in 2000?
Give a very brief answer. 1.50e+07. What is the difference between the Aid flow from UN agencies (US$) of Aruba in 1996 and the Aid flow from UN agencies (US$) of Cambodia in 2000?
Give a very brief answer. -2.60e+06. What is the difference between the Aid flow from UN agencies (US$) in Aruba in 1996 and the Aid flow from UN agencies (US$) in Kenya in 2000?
Your response must be concise. -2.23e+06. What is the difference between the Aid flow from UN agencies (US$) in Cambodia in 1996 and the Aid flow from UN agencies (US$) in Kenya in 2000?
Offer a very short reply. -6.70e+05. What is the difference between the Aid flow from UN agencies (US$) in South Asia in 1998 and the Aid flow from UN agencies (US$) in Aruba in 1999?
Provide a succinct answer. 1.72e+07. What is the difference between the Aid flow from UN agencies (US$) of South Asia in 1998 and the Aid flow from UN agencies (US$) of Cambodia in 1999?
Your answer should be compact. 1.51e+07. What is the difference between the Aid flow from UN agencies (US$) in South Asia in 1998 and the Aid flow from UN agencies (US$) in Kenya in 1999?
Offer a very short reply. 1.52e+07. What is the difference between the Aid flow from UN agencies (US$) of Aruba in 1998 and the Aid flow from UN agencies (US$) of Cambodia in 1999?
Offer a terse response. -2.12e+06. What is the difference between the Aid flow from UN agencies (US$) in Aruba in 1998 and the Aid flow from UN agencies (US$) in Kenya in 1999?
Provide a succinct answer. -1.97e+06. What is the difference between the Aid flow from UN agencies (US$) of Cambodia in 1998 and the Aid flow from UN agencies (US$) of Kenya in 1999?
Ensure brevity in your answer.  -7.50e+05. What is the difference between the Aid flow from UN agencies (US$) in South Asia in 1998 and the Aid flow from UN agencies (US$) in Aruba in 2000?
Ensure brevity in your answer.  1.72e+07. What is the difference between the Aid flow from UN agencies (US$) in South Asia in 1998 and the Aid flow from UN agencies (US$) in Cambodia in 2000?
Offer a terse response. 1.46e+07. What is the difference between the Aid flow from UN agencies (US$) in South Asia in 1998 and the Aid flow from UN agencies (US$) in Kenya in 2000?
Ensure brevity in your answer.  1.50e+07. What is the difference between the Aid flow from UN agencies (US$) in Aruba in 1998 and the Aid flow from UN agencies (US$) in Cambodia in 2000?
Your response must be concise. -2.57e+06. What is the difference between the Aid flow from UN agencies (US$) of Aruba in 1998 and the Aid flow from UN agencies (US$) of Kenya in 2000?
Your response must be concise. -2.20e+06. What is the difference between the Aid flow from UN agencies (US$) of Cambodia in 1998 and the Aid flow from UN agencies (US$) of Kenya in 2000?
Keep it short and to the point. -9.80e+05. What is the difference between the Aid flow from UN agencies (US$) of South Asia in 1999 and the Aid flow from UN agencies (US$) of Aruba in 2000?
Your answer should be very brief. 3.26e+07. What is the difference between the Aid flow from UN agencies (US$) in South Asia in 1999 and the Aid flow from UN agencies (US$) in Cambodia in 2000?
Offer a very short reply. 3.01e+07. What is the difference between the Aid flow from UN agencies (US$) of South Asia in 1999 and the Aid flow from UN agencies (US$) of Kenya in 2000?
Keep it short and to the point. 3.05e+07. What is the difference between the Aid flow from UN agencies (US$) in Aruba in 1999 and the Aid flow from UN agencies (US$) in Cambodia in 2000?
Give a very brief answer. -2.60e+06. What is the difference between the Aid flow from UN agencies (US$) of Aruba in 1999 and the Aid flow from UN agencies (US$) of Kenya in 2000?
Your response must be concise. -2.23e+06. What is the average Aid flow from UN agencies (US$) in South Asia per year?
Provide a succinct answer. 2.41e+07. What is the average Aid flow from UN agencies (US$) of Aruba per year?
Your answer should be compact. 3.62e+04. What is the average Aid flow from UN agencies (US$) in Cambodia per year?
Provide a short and direct response. 1.50e+06. What is the average Aid flow from UN agencies (US$) in Kenya per year?
Keep it short and to the point. 1.81e+06. In the year 1991, what is the difference between the Aid flow from UN agencies (US$) in South Asia and Aid flow from UN agencies (US$) in Aruba?
Ensure brevity in your answer.  2.71e+07. In the year 1991, what is the difference between the Aid flow from UN agencies (US$) in South Asia and Aid flow from UN agencies (US$) in Cambodia?
Your response must be concise. 2.68e+07. In the year 1991, what is the difference between the Aid flow from UN agencies (US$) of South Asia and Aid flow from UN agencies (US$) of Kenya?
Your response must be concise. 2.56e+07. In the year 1991, what is the difference between the Aid flow from UN agencies (US$) in Aruba and Aid flow from UN agencies (US$) in Cambodia?
Provide a succinct answer. -2.80e+05. In the year 1991, what is the difference between the Aid flow from UN agencies (US$) of Aruba and Aid flow from UN agencies (US$) of Kenya?
Provide a succinct answer. -1.52e+06. In the year 1991, what is the difference between the Aid flow from UN agencies (US$) of Cambodia and Aid flow from UN agencies (US$) of Kenya?
Provide a short and direct response. -1.24e+06. In the year 1992, what is the difference between the Aid flow from UN agencies (US$) of South Asia and Aid flow from UN agencies (US$) of Aruba?
Provide a succinct answer. 1.56e+07. In the year 1992, what is the difference between the Aid flow from UN agencies (US$) of South Asia and Aid flow from UN agencies (US$) of Cambodia?
Keep it short and to the point. 1.44e+07. In the year 1992, what is the difference between the Aid flow from UN agencies (US$) in South Asia and Aid flow from UN agencies (US$) in Kenya?
Your answer should be compact. 1.38e+07. In the year 1992, what is the difference between the Aid flow from UN agencies (US$) of Aruba and Aid flow from UN agencies (US$) of Cambodia?
Keep it short and to the point. -1.22e+06. In the year 1992, what is the difference between the Aid flow from UN agencies (US$) of Aruba and Aid flow from UN agencies (US$) of Kenya?
Your answer should be compact. -1.75e+06. In the year 1992, what is the difference between the Aid flow from UN agencies (US$) in Cambodia and Aid flow from UN agencies (US$) in Kenya?
Provide a succinct answer. -5.30e+05. In the year 1993, what is the difference between the Aid flow from UN agencies (US$) of South Asia and Aid flow from UN agencies (US$) of Aruba?
Provide a succinct answer. 3.29e+07. In the year 1993, what is the difference between the Aid flow from UN agencies (US$) of South Asia and Aid flow from UN agencies (US$) of Cambodia?
Your answer should be compact. 3.13e+07. In the year 1993, what is the difference between the Aid flow from UN agencies (US$) of South Asia and Aid flow from UN agencies (US$) of Kenya?
Keep it short and to the point. 3.06e+07. In the year 1993, what is the difference between the Aid flow from UN agencies (US$) of Aruba and Aid flow from UN agencies (US$) of Cambodia?
Make the answer very short. -1.64e+06. In the year 1993, what is the difference between the Aid flow from UN agencies (US$) of Aruba and Aid flow from UN agencies (US$) of Kenya?
Give a very brief answer. -2.31e+06. In the year 1993, what is the difference between the Aid flow from UN agencies (US$) in Cambodia and Aid flow from UN agencies (US$) in Kenya?
Ensure brevity in your answer.  -6.70e+05. In the year 1994, what is the difference between the Aid flow from UN agencies (US$) in South Asia and Aid flow from UN agencies (US$) in Aruba?
Keep it short and to the point. 1.71e+07. In the year 1994, what is the difference between the Aid flow from UN agencies (US$) of South Asia and Aid flow from UN agencies (US$) of Cambodia?
Keep it short and to the point. 1.60e+07. In the year 1994, what is the difference between the Aid flow from UN agencies (US$) of South Asia and Aid flow from UN agencies (US$) of Kenya?
Provide a succinct answer. 1.57e+07. In the year 1994, what is the difference between the Aid flow from UN agencies (US$) in Aruba and Aid flow from UN agencies (US$) in Cambodia?
Provide a succinct answer. -1.14e+06. In the year 1994, what is the difference between the Aid flow from UN agencies (US$) of Aruba and Aid flow from UN agencies (US$) of Kenya?
Offer a very short reply. -1.42e+06. In the year 1994, what is the difference between the Aid flow from UN agencies (US$) in Cambodia and Aid flow from UN agencies (US$) in Kenya?
Provide a short and direct response. -2.80e+05. In the year 1996, what is the difference between the Aid flow from UN agencies (US$) in South Asia and Aid flow from UN agencies (US$) in Aruba?
Ensure brevity in your answer.  1.72e+07. In the year 1996, what is the difference between the Aid flow from UN agencies (US$) of South Asia and Aid flow from UN agencies (US$) of Cambodia?
Your response must be concise. 1.56e+07. In the year 1996, what is the difference between the Aid flow from UN agencies (US$) in South Asia and Aid flow from UN agencies (US$) in Kenya?
Give a very brief answer. 1.59e+07. In the year 1996, what is the difference between the Aid flow from UN agencies (US$) in Aruba and Aid flow from UN agencies (US$) in Cambodia?
Your answer should be very brief. -1.56e+06. In the year 1996, what is the difference between the Aid flow from UN agencies (US$) of Aruba and Aid flow from UN agencies (US$) of Kenya?
Your answer should be compact. -1.31e+06. In the year 1998, what is the difference between the Aid flow from UN agencies (US$) in South Asia and Aid flow from UN agencies (US$) in Aruba?
Keep it short and to the point. 1.72e+07. In the year 1998, what is the difference between the Aid flow from UN agencies (US$) in South Asia and Aid flow from UN agencies (US$) in Cambodia?
Your response must be concise. 1.60e+07. In the year 1998, what is the difference between the Aid flow from UN agencies (US$) in South Asia and Aid flow from UN agencies (US$) in Kenya?
Your response must be concise. 1.54e+07. In the year 1998, what is the difference between the Aid flow from UN agencies (US$) in Aruba and Aid flow from UN agencies (US$) in Cambodia?
Offer a very short reply. -1.22e+06. In the year 1998, what is the difference between the Aid flow from UN agencies (US$) of Aruba and Aid flow from UN agencies (US$) of Kenya?
Ensure brevity in your answer.  -1.73e+06. In the year 1998, what is the difference between the Aid flow from UN agencies (US$) of Cambodia and Aid flow from UN agencies (US$) of Kenya?
Make the answer very short. -5.10e+05. In the year 1999, what is the difference between the Aid flow from UN agencies (US$) of South Asia and Aid flow from UN agencies (US$) of Aruba?
Keep it short and to the point. 3.27e+07. In the year 1999, what is the difference between the Aid flow from UN agencies (US$) of South Asia and Aid flow from UN agencies (US$) of Cambodia?
Offer a terse response. 3.05e+07. In the year 1999, what is the difference between the Aid flow from UN agencies (US$) of South Asia and Aid flow from UN agencies (US$) of Kenya?
Keep it short and to the point. 3.07e+07. In the year 1999, what is the difference between the Aid flow from UN agencies (US$) of Aruba and Aid flow from UN agencies (US$) of Cambodia?
Provide a succinct answer. -2.15e+06. In the year 1999, what is the difference between the Aid flow from UN agencies (US$) of Aruba and Aid flow from UN agencies (US$) of Kenya?
Offer a terse response. -2.00e+06. In the year 1999, what is the difference between the Aid flow from UN agencies (US$) in Cambodia and Aid flow from UN agencies (US$) in Kenya?
Make the answer very short. 1.50e+05. In the year 2000, what is the difference between the Aid flow from UN agencies (US$) in South Asia and Aid flow from UN agencies (US$) in Aruba?
Provide a short and direct response. 3.25e+07. In the year 2000, what is the difference between the Aid flow from UN agencies (US$) in South Asia and Aid flow from UN agencies (US$) in Cambodia?
Provide a short and direct response. 3.00e+07. In the year 2000, what is the difference between the Aid flow from UN agencies (US$) of South Asia and Aid flow from UN agencies (US$) of Kenya?
Your answer should be compact. 3.03e+07. In the year 2000, what is the difference between the Aid flow from UN agencies (US$) of Aruba and Aid flow from UN agencies (US$) of Cambodia?
Your response must be concise. -2.54e+06. In the year 2000, what is the difference between the Aid flow from UN agencies (US$) of Aruba and Aid flow from UN agencies (US$) of Kenya?
Your response must be concise. -2.17e+06. In the year 2000, what is the difference between the Aid flow from UN agencies (US$) of Cambodia and Aid flow from UN agencies (US$) of Kenya?
Keep it short and to the point. 3.70e+05. What is the ratio of the Aid flow from UN agencies (US$) in South Asia in 1991 to that in 1992?
Your answer should be very brief. 1.74. What is the ratio of the Aid flow from UN agencies (US$) in Aruba in 1991 to that in 1992?
Keep it short and to the point. 1. What is the ratio of the Aid flow from UN agencies (US$) of Cambodia in 1991 to that in 1992?
Give a very brief answer. 0.24. What is the ratio of the Aid flow from UN agencies (US$) in Kenya in 1991 to that in 1992?
Offer a terse response. 0.87. What is the ratio of the Aid flow from UN agencies (US$) in South Asia in 1991 to that in 1993?
Your answer should be very brief. 0.82. What is the ratio of the Aid flow from UN agencies (US$) in Cambodia in 1991 to that in 1993?
Offer a terse response. 0.17. What is the ratio of the Aid flow from UN agencies (US$) in Kenya in 1991 to that in 1993?
Your response must be concise. 0.66. What is the ratio of the Aid flow from UN agencies (US$) of South Asia in 1991 to that in 1994?
Make the answer very short. 1.58. What is the ratio of the Aid flow from UN agencies (US$) of Cambodia in 1991 to that in 1994?
Make the answer very short. 0.25. What is the ratio of the Aid flow from UN agencies (US$) in Kenya in 1991 to that in 1994?
Your response must be concise. 1.05. What is the ratio of the Aid flow from UN agencies (US$) of South Asia in 1991 to that in 1996?
Offer a very short reply. 1.58. What is the ratio of the Aid flow from UN agencies (US$) of Aruba in 1991 to that in 1996?
Your response must be concise. 0.33. What is the ratio of the Aid flow from UN agencies (US$) in Cambodia in 1991 to that in 1996?
Keep it short and to the point. 0.18. What is the ratio of the Aid flow from UN agencies (US$) of Kenya in 1991 to that in 1996?
Your response must be concise. 1.14. What is the ratio of the Aid flow from UN agencies (US$) of South Asia in 1991 to that in 1998?
Offer a very short reply. 1.57. What is the ratio of the Aid flow from UN agencies (US$) of Cambodia in 1991 to that in 1998?
Your answer should be compact. 0.23. What is the ratio of the Aid flow from UN agencies (US$) in Kenya in 1991 to that in 1998?
Your response must be concise. 0.85. What is the ratio of the Aid flow from UN agencies (US$) of South Asia in 1991 to that in 1999?
Your answer should be very brief. 0.83. What is the ratio of the Aid flow from UN agencies (US$) in Cambodia in 1991 to that in 1999?
Provide a short and direct response. 0.13. What is the ratio of the Aid flow from UN agencies (US$) in Kenya in 1991 to that in 1999?
Your answer should be very brief. 0.75. What is the ratio of the Aid flow from UN agencies (US$) in South Asia in 1991 to that in 2000?
Provide a short and direct response. 0.83. What is the ratio of the Aid flow from UN agencies (US$) in Cambodia in 1991 to that in 2000?
Keep it short and to the point. 0.11. What is the ratio of the Aid flow from UN agencies (US$) in Kenya in 1991 to that in 2000?
Provide a short and direct response. 0.68. What is the ratio of the Aid flow from UN agencies (US$) in South Asia in 1992 to that in 1993?
Ensure brevity in your answer.  0.47. What is the ratio of the Aid flow from UN agencies (US$) of Aruba in 1992 to that in 1993?
Offer a very short reply. 0.5. What is the ratio of the Aid flow from UN agencies (US$) of Cambodia in 1992 to that in 1993?
Offer a terse response. 0.74. What is the ratio of the Aid flow from UN agencies (US$) in Kenya in 1992 to that in 1993?
Give a very brief answer. 0.76. What is the ratio of the Aid flow from UN agencies (US$) of South Asia in 1992 to that in 1994?
Offer a very short reply. 0.91. What is the ratio of the Aid flow from UN agencies (US$) in Cambodia in 1992 to that in 1994?
Offer a very short reply. 1.04. What is the ratio of the Aid flow from UN agencies (US$) of Kenya in 1992 to that in 1994?
Your answer should be very brief. 1.21. What is the ratio of the Aid flow from UN agencies (US$) of South Asia in 1992 to that in 1996?
Ensure brevity in your answer.  0.91. What is the ratio of the Aid flow from UN agencies (US$) in Aruba in 1992 to that in 1996?
Offer a very short reply. 0.33. What is the ratio of the Aid flow from UN agencies (US$) of Cambodia in 1992 to that in 1996?
Offer a terse response. 0.77. What is the ratio of the Aid flow from UN agencies (US$) of Kenya in 1992 to that in 1996?
Provide a short and direct response. 1.31. What is the ratio of the Aid flow from UN agencies (US$) of South Asia in 1992 to that in 1998?
Your answer should be very brief. 0.91. What is the ratio of the Aid flow from UN agencies (US$) of Aruba in 1992 to that in 1998?
Make the answer very short. 0.17. What is the ratio of the Aid flow from UN agencies (US$) in Cambodia in 1992 to that in 1998?
Provide a short and direct response. 0.96. What is the ratio of the Aid flow from UN agencies (US$) of Kenya in 1992 to that in 1998?
Your answer should be very brief. 0.98. What is the ratio of the Aid flow from UN agencies (US$) in South Asia in 1992 to that in 1999?
Your response must be concise. 0.48. What is the ratio of the Aid flow from UN agencies (US$) of Aruba in 1992 to that in 1999?
Provide a succinct answer. 0.33. What is the ratio of the Aid flow from UN agencies (US$) in Cambodia in 1992 to that in 1999?
Offer a terse response. 0.56. What is the ratio of the Aid flow from UN agencies (US$) in Kenya in 1992 to that in 1999?
Make the answer very short. 0.87. What is the ratio of the Aid flow from UN agencies (US$) of South Asia in 1992 to that in 2000?
Make the answer very short. 0.48. What is the ratio of the Aid flow from UN agencies (US$) in Cambodia in 1992 to that in 2000?
Offer a terse response. 0.47. What is the ratio of the Aid flow from UN agencies (US$) of Kenya in 1992 to that in 2000?
Offer a very short reply. 0.78. What is the ratio of the Aid flow from UN agencies (US$) in South Asia in 1993 to that in 1994?
Your answer should be compact. 1.92. What is the ratio of the Aid flow from UN agencies (US$) in Aruba in 1993 to that in 1994?
Keep it short and to the point. 0.5. What is the ratio of the Aid flow from UN agencies (US$) in Cambodia in 1993 to that in 1994?
Provide a short and direct response. 1.41. What is the ratio of the Aid flow from UN agencies (US$) in Kenya in 1993 to that in 1994?
Your answer should be compact. 1.6. What is the ratio of the Aid flow from UN agencies (US$) in South Asia in 1993 to that in 1996?
Ensure brevity in your answer.  1.91. What is the ratio of the Aid flow from UN agencies (US$) in Cambodia in 1993 to that in 1996?
Offer a terse response. 1.04. What is the ratio of the Aid flow from UN agencies (US$) of Kenya in 1993 to that in 1996?
Offer a very short reply. 1.74. What is the ratio of the Aid flow from UN agencies (US$) in South Asia in 1993 to that in 1998?
Your response must be concise. 1.91. What is the ratio of the Aid flow from UN agencies (US$) in Aruba in 1993 to that in 1998?
Give a very brief answer. 0.33. What is the ratio of the Aid flow from UN agencies (US$) of Cambodia in 1993 to that in 1998?
Ensure brevity in your answer.  1.3. What is the ratio of the Aid flow from UN agencies (US$) in Kenya in 1993 to that in 1998?
Provide a succinct answer. 1.3. What is the ratio of the Aid flow from UN agencies (US$) of Cambodia in 1993 to that in 1999?
Your answer should be very brief. 0.76. What is the ratio of the Aid flow from UN agencies (US$) of Kenya in 1993 to that in 1999?
Keep it short and to the point. 1.15. What is the ratio of the Aid flow from UN agencies (US$) of South Asia in 1993 to that in 2000?
Provide a succinct answer. 1.01. What is the ratio of the Aid flow from UN agencies (US$) in Aruba in 1993 to that in 2000?
Make the answer very short. 0.22. What is the ratio of the Aid flow from UN agencies (US$) in Cambodia in 1993 to that in 2000?
Ensure brevity in your answer.  0.63. What is the ratio of the Aid flow from UN agencies (US$) of Kenya in 1993 to that in 2000?
Keep it short and to the point. 1.03. What is the ratio of the Aid flow from UN agencies (US$) of Aruba in 1994 to that in 1996?
Provide a succinct answer. 1.33. What is the ratio of the Aid flow from UN agencies (US$) of Cambodia in 1994 to that in 1996?
Give a very brief answer. 0.74. What is the ratio of the Aid flow from UN agencies (US$) in Kenya in 1994 to that in 1996?
Give a very brief answer. 1.09. What is the ratio of the Aid flow from UN agencies (US$) of Aruba in 1994 to that in 1998?
Provide a short and direct response. 0.67. What is the ratio of the Aid flow from UN agencies (US$) in Cambodia in 1994 to that in 1998?
Offer a terse response. 0.92. What is the ratio of the Aid flow from UN agencies (US$) in Kenya in 1994 to that in 1998?
Provide a short and direct response. 0.82. What is the ratio of the Aid flow from UN agencies (US$) in South Asia in 1994 to that in 1999?
Ensure brevity in your answer.  0.52. What is the ratio of the Aid flow from UN agencies (US$) in Cambodia in 1994 to that in 1999?
Keep it short and to the point. 0.54. What is the ratio of the Aid flow from UN agencies (US$) of Kenya in 1994 to that in 1999?
Offer a terse response. 0.72. What is the ratio of the Aid flow from UN agencies (US$) in South Asia in 1994 to that in 2000?
Ensure brevity in your answer.  0.53. What is the ratio of the Aid flow from UN agencies (US$) of Aruba in 1994 to that in 2000?
Ensure brevity in your answer.  0.44. What is the ratio of the Aid flow from UN agencies (US$) of Cambodia in 1994 to that in 2000?
Give a very brief answer. 0.45. What is the ratio of the Aid flow from UN agencies (US$) of Kenya in 1994 to that in 2000?
Your answer should be compact. 0.65. What is the ratio of the Aid flow from UN agencies (US$) in Aruba in 1996 to that in 1998?
Offer a terse response. 0.5. What is the ratio of the Aid flow from UN agencies (US$) in Cambodia in 1996 to that in 1998?
Your answer should be compact. 1.24. What is the ratio of the Aid flow from UN agencies (US$) of Kenya in 1996 to that in 1998?
Provide a short and direct response. 0.75. What is the ratio of the Aid flow from UN agencies (US$) in South Asia in 1996 to that in 1999?
Your answer should be compact. 0.53. What is the ratio of the Aid flow from UN agencies (US$) in Cambodia in 1996 to that in 1999?
Make the answer very short. 0.73. What is the ratio of the Aid flow from UN agencies (US$) of Kenya in 1996 to that in 1999?
Provide a succinct answer. 0.66. What is the ratio of the Aid flow from UN agencies (US$) of South Asia in 1996 to that in 2000?
Ensure brevity in your answer.  0.53. What is the ratio of the Aid flow from UN agencies (US$) in Cambodia in 1996 to that in 2000?
Your answer should be very brief. 0.6. What is the ratio of the Aid flow from UN agencies (US$) in Kenya in 1996 to that in 2000?
Provide a succinct answer. 0.59. What is the ratio of the Aid flow from UN agencies (US$) of South Asia in 1998 to that in 1999?
Offer a terse response. 0.53. What is the ratio of the Aid flow from UN agencies (US$) in Cambodia in 1998 to that in 1999?
Your answer should be compact. 0.59. What is the ratio of the Aid flow from UN agencies (US$) of Kenya in 1998 to that in 1999?
Make the answer very short. 0.88. What is the ratio of the Aid flow from UN agencies (US$) in South Asia in 1998 to that in 2000?
Offer a very short reply. 0.53. What is the ratio of the Aid flow from UN agencies (US$) in Cambodia in 1998 to that in 2000?
Give a very brief answer. 0.49. What is the ratio of the Aid flow from UN agencies (US$) in Kenya in 1998 to that in 2000?
Provide a short and direct response. 0.79. What is the ratio of the Aid flow from UN agencies (US$) of Cambodia in 1999 to that in 2000?
Keep it short and to the point. 0.83. What is the ratio of the Aid flow from UN agencies (US$) of Kenya in 1999 to that in 2000?
Your response must be concise. 0.9. What is the difference between the highest and the second highest Aid flow from UN agencies (US$) of South Asia?
Ensure brevity in your answer.  2.30e+05. What is the difference between the highest and the lowest Aid flow from UN agencies (US$) in South Asia?
Provide a succinct answer. 1.73e+07. What is the difference between the highest and the lowest Aid flow from UN agencies (US$) in Cambodia?
Keep it short and to the point. 2.34e+06. What is the difference between the highest and the lowest Aid flow from UN agencies (US$) of Kenya?
Provide a short and direct response. 9.90e+05. 